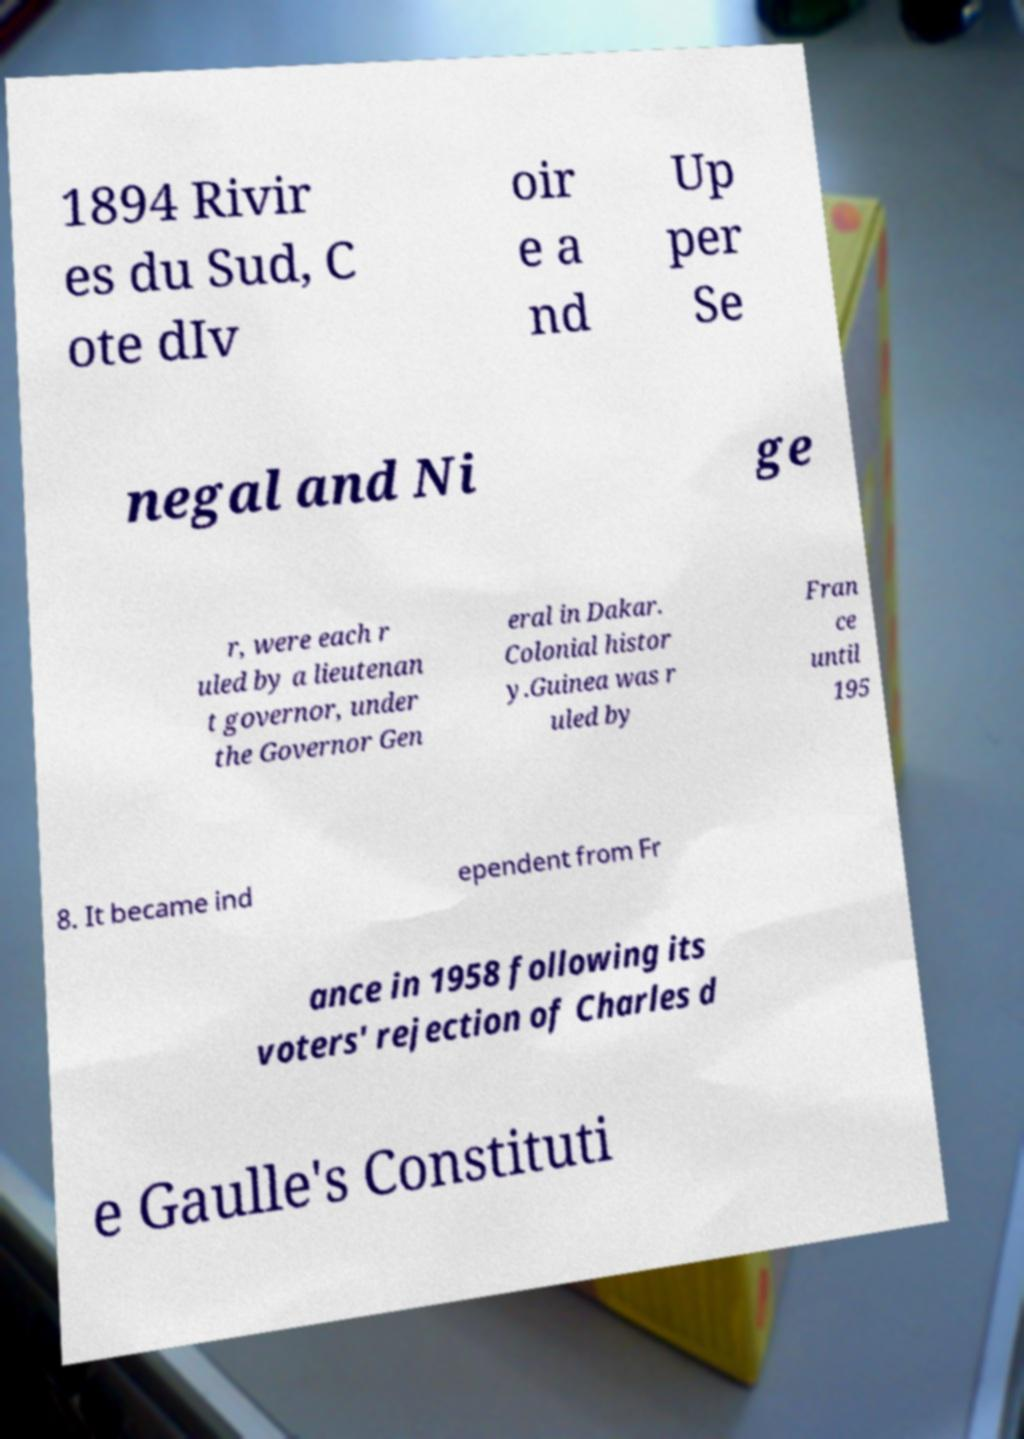For documentation purposes, I need the text within this image transcribed. Could you provide that? 1894 Rivir es du Sud, C ote dIv oir e a nd Up per Se negal and Ni ge r, were each r uled by a lieutenan t governor, under the Governor Gen eral in Dakar. Colonial histor y.Guinea was r uled by Fran ce until 195 8. It became ind ependent from Fr ance in 1958 following its voters' rejection of Charles d e Gaulle's Constituti 